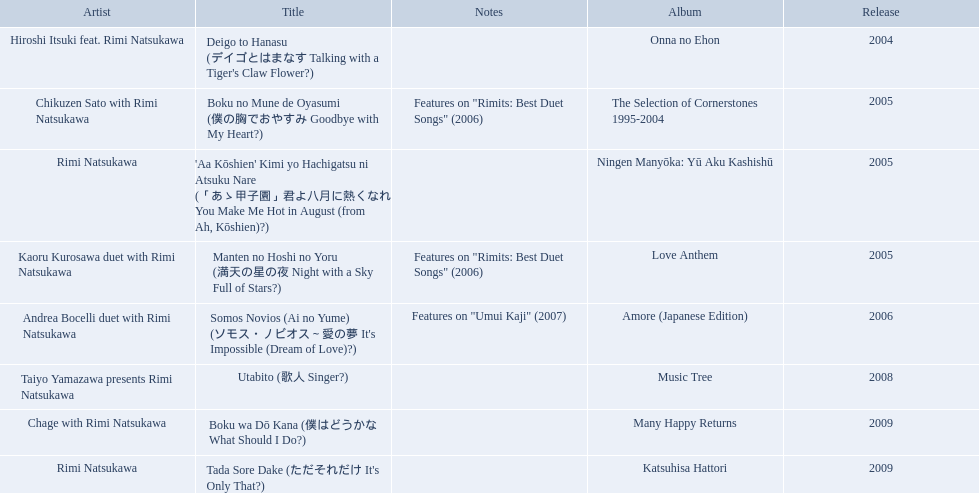What are the names of each album by rimi natsukawa? Onna no Ehon, The Selection of Cornerstones 1995-2004, Ningen Manyōka: Yū Aku Kashishū, Love Anthem, Amore (Japanese Edition), Music Tree, Many Happy Returns, Katsuhisa Hattori. And when were the albums released? 2004, 2005, 2005, 2005, 2006, 2008, 2009, 2009. Would you mind parsing the complete table? {'header': ['Artist', 'Title', 'Notes', 'Album', 'Release'], 'rows': [['Hiroshi Itsuki feat. Rimi Natsukawa', "Deigo to Hanasu (デイゴとはまなす Talking with a Tiger's Claw Flower?)", '', 'Onna no Ehon', '2004'], ['Chikuzen Sato with Rimi Natsukawa', 'Boku no Mune de Oyasumi (僕の胸でおやすみ Goodbye with My Heart?)', 'Features on "Rimits: Best Duet Songs" (2006)', 'The Selection of Cornerstones 1995-2004', '2005'], ['Rimi Natsukawa', "'Aa Kōshien' Kimi yo Hachigatsu ni Atsuku Nare (「あゝ甲子園」君よ八月に熱くなれ You Make Me Hot in August (from Ah, Kōshien)?)", '', 'Ningen Manyōka: Yū Aku Kashishū', '2005'], ['Kaoru Kurosawa duet with Rimi Natsukawa', 'Manten no Hoshi no Yoru (満天の星の夜 Night with a Sky Full of Stars?)', 'Features on "Rimits: Best Duet Songs" (2006)', 'Love Anthem', '2005'], ['Andrea Bocelli duet with Rimi Natsukawa', "Somos Novios (Ai no Yume) (ソモス・ノビオス～愛の夢 It's Impossible (Dream of Love)?)", 'Features on "Umui Kaji" (2007)', 'Amore (Japanese Edition)', '2006'], ['Taiyo Yamazawa presents Rimi Natsukawa', 'Utabito (歌人 Singer?)', '', 'Music Tree', '2008'], ['Chage with Rimi Natsukawa', 'Boku wa Dō Kana (僕はどうかな What Should I Do?)', '', 'Many Happy Returns', '2009'], ['Rimi Natsukawa', "Tada Sore Dake (ただそれだけ It's Only That?)", '', 'Katsuhisa Hattori', '2009']]} Was onna no ehon or music tree released most recently? Music Tree. 